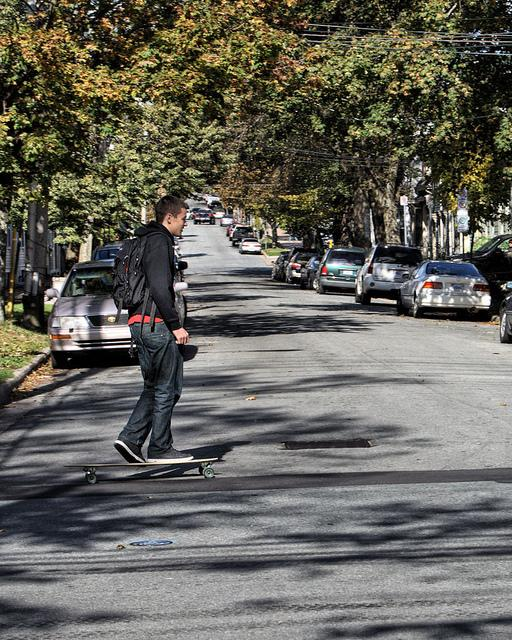What country does the white car originate from?

Choices:
A) israel
B) america
C) japan
D) canada japan 